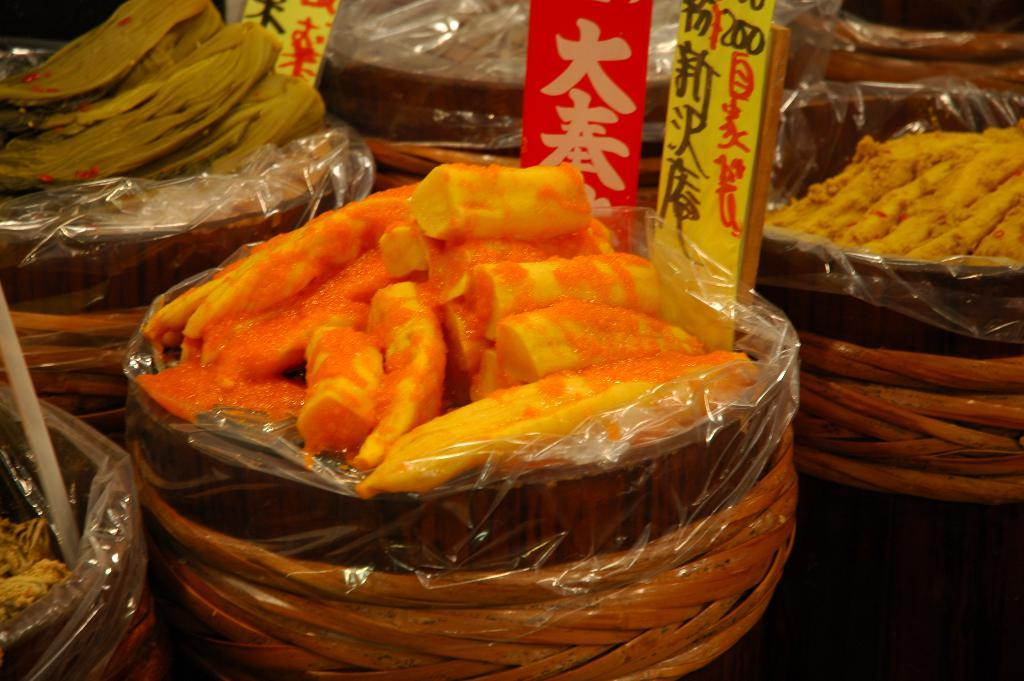What type of objects are present in the image that contain food? There are bowls in the image that contain food. What information can be gathered from the labels visible in the image? The labels provide information about the food items in the bowls. What type of attack can be seen in the image? There is no attack present in the image; it features food items in bowls with labels. What type of cannon is visible in the image? There is no cannon present in the image. 